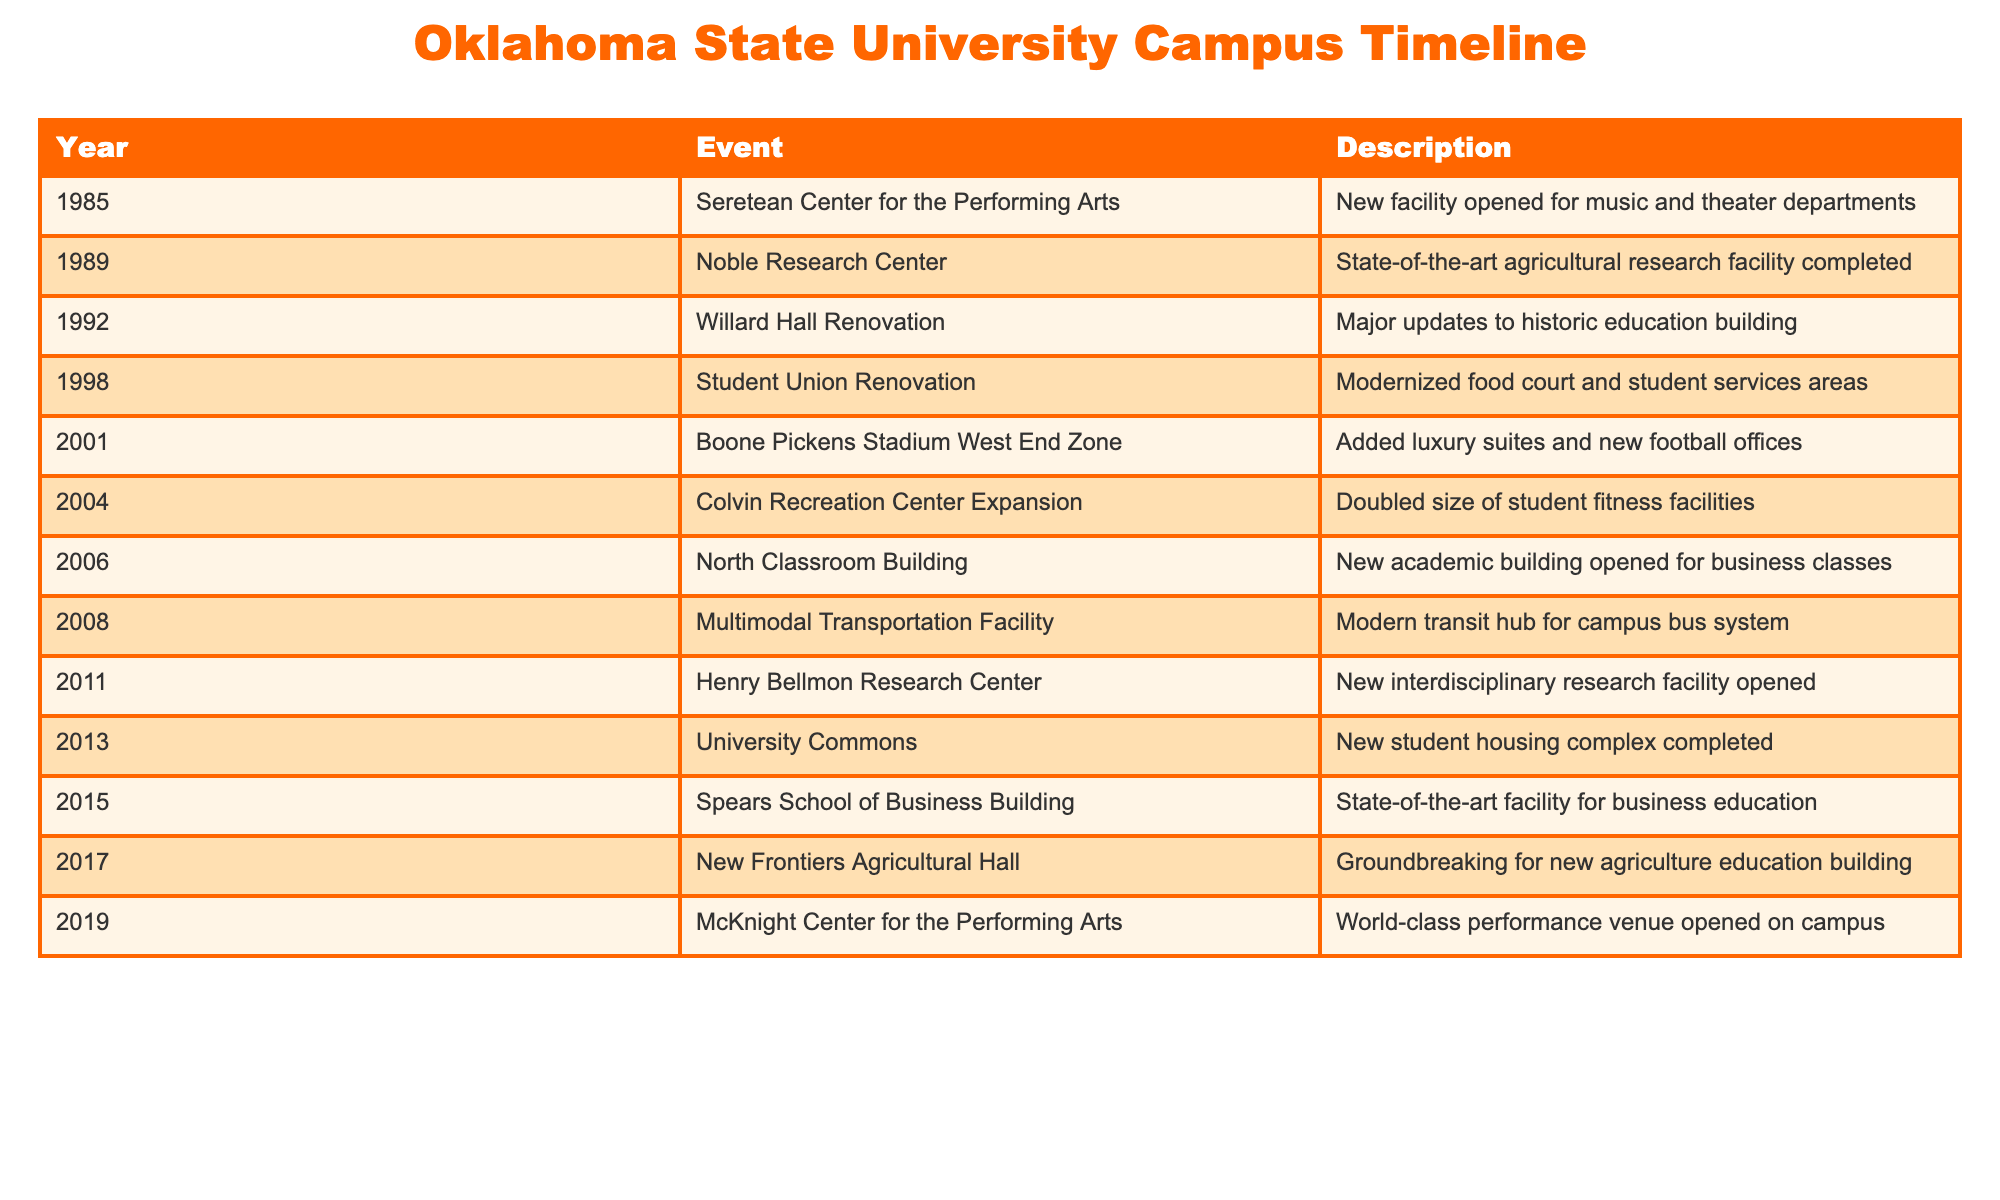What year was the Boone Pickens Stadium West End Zone completed? The table shows that the Boone Pickens Stadium West End Zone was completed in 2001.
Answer: 2001 Which event related to the performing arts happened in 2019? According to the table, the McKnight Center for the Performing Arts opened in 2019.
Answer: McKnight Center for the Performing Arts How many years passed between the opening of the Noble Research Center and the Colvin Recreation Center Expansion? The Noble Research Center opened in 1989 and the Colvin Recreation Center Expansion occurred in 2004. The difference in years is 2004 - 1989 = 15 years.
Answer: 15 years Was there any significant renovation of educational facilities between 1980 and 2000? Yes, Willard Hall Renovation occurred in 1992 and major updates were made to the building.
Answer: Yes Which two facilities were opened for research purposes and in what years? The table lists the Noble Research Center (1989) and the Henry Bellmon Research Center (2011) as research facilities.
Answer: Noble Research Center (1989), Henry Bellmon Research Center (2011) What is the average year of completion for the events listed in the table? To find the average, we first sum the years: 1985 + 1989 + 1992 + 1998 + 2001 + 2004 + 2006 + 2008 + 2011 + 2013 + 2015 + 2017 + 2019 = 20036. There are 13 events, so the average is 20036 / 13 = 1549.923, rounding to 2010.
Answer: 2010 What percentage of the events in the table are related to student housing? The table indicates that there is 1 event related to student housing (University Commons in 2013) out of 13 total events. The percentage is (1/13) * 100 = 7.69%.
Answer: 7.69% When was the last campus expansion mentioned in the table and what was it? The last event listed is the McKnight Center for the Performing Arts which opened in 2019.
Answer: 2019, McKnight Center for the Performing Arts Did the campus expansion and renovation events mostly focus on sports facilities or performing arts centers? Based on the table, while there are sports facilities (e.g., Boone Pickens Stadium) and a performing arts center (McKnight Center), there are more events related to educational, research, and housing facilities overall. Thus, the focus is broader than just sports or performing arts.
Answer: Broader focus than just sports or performing arts 